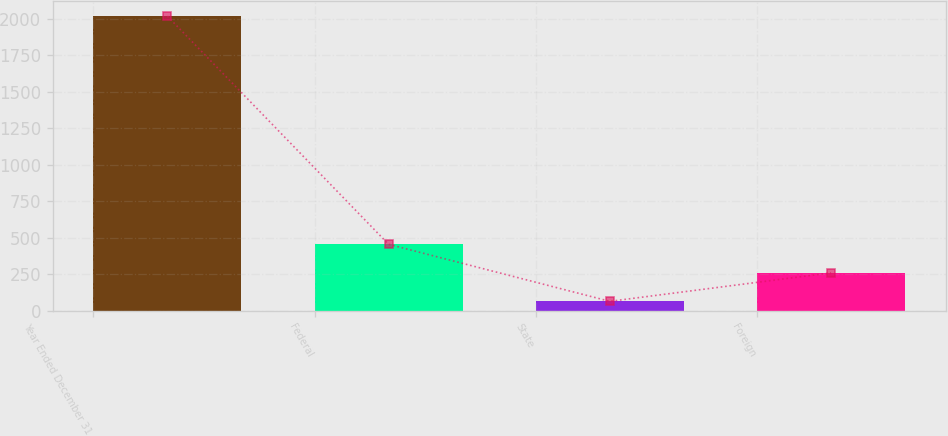Convert chart to OTSL. <chart><loc_0><loc_0><loc_500><loc_500><bar_chart><fcel>Year Ended December 31<fcel>Federal<fcel>State<fcel>Foreign<nl><fcel>2017<fcel>454.44<fcel>63.8<fcel>259.12<nl></chart> 